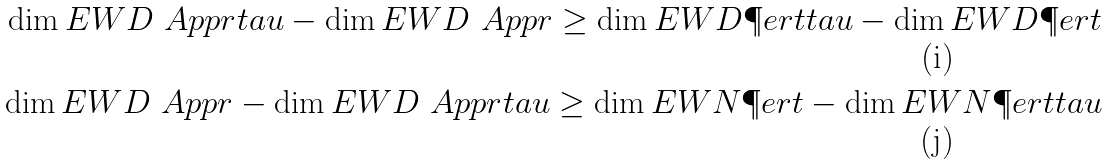Convert formula to latex. <formula><loc_0><loc_0><loc_500><loc_500>\dim E W D \ A p p r t a u - \dim E W D \ A p p r \geq \dim E W D \P e r t t a u - \dim E W D \P e r t \\ \dim E W D \ A p p r - \dim E W D \ A p p r t a u \geq \dim E W N \P e r t - \dim E W N \P e r t t a u</formula> 